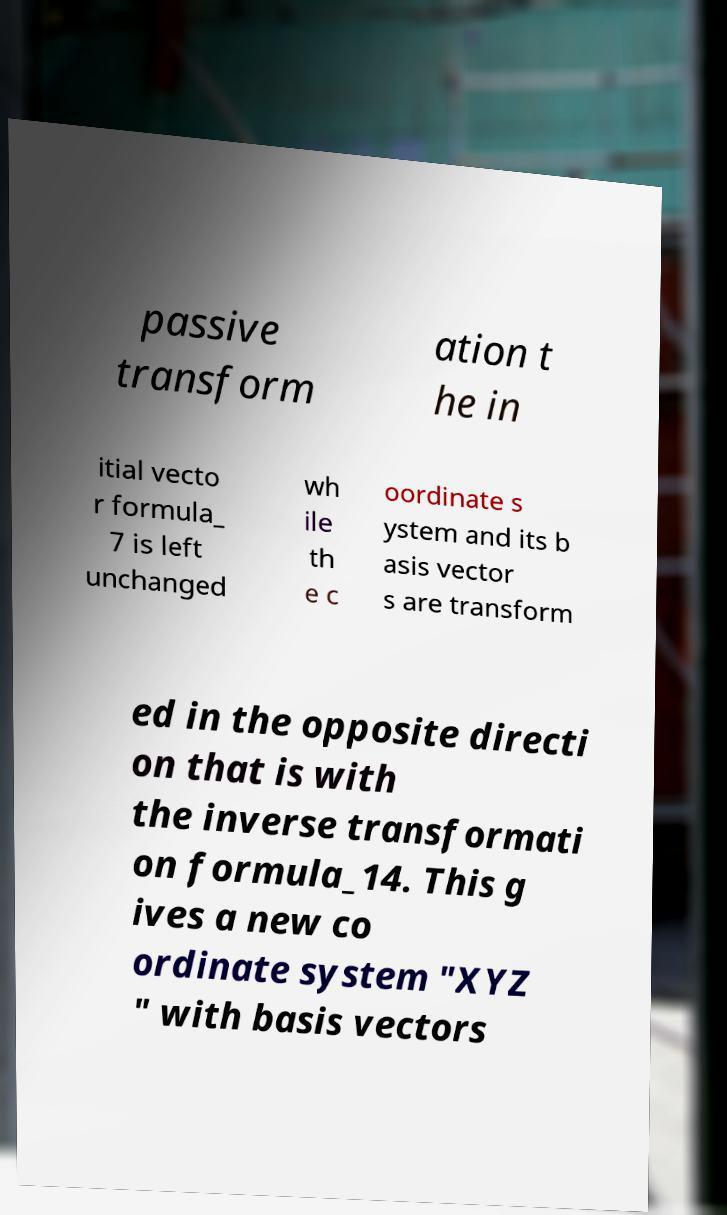What messages or text are displayed in this image? I need them in a readable, typed format. passive transform ation t he in itial vecto r formula_ 7 is left unchanged wh ile th e c oordinate s ystem and its b asis vector s are transform ed in the opposite directi on that is with the inverse transformati on formula_14. This g ives a new co ordinate system "XYZ " with basis vectors 